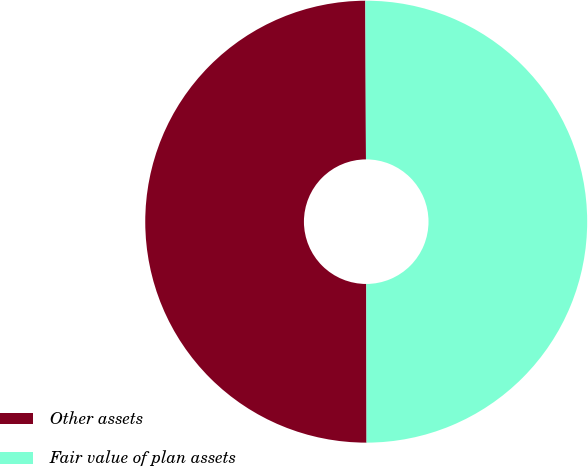Convert chart to OTSL. <chart><loc_0><loc_0><loc_500><loc_500><pie_chart><fcel>Other assets<fcel>Fair value of plan assets<nl><fcel>49.96%<fcel>50.04%<nl></chart> 